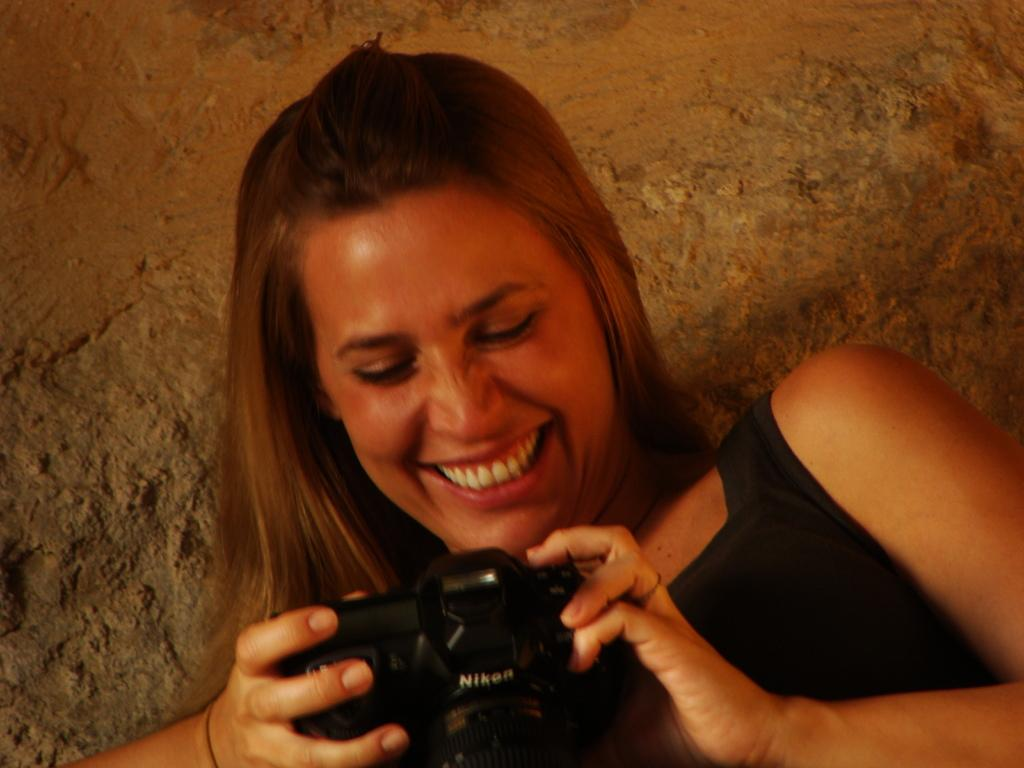Who is the main subject in the image? There is a woman in the image. What is the woman wearing? The woman is wearing a black dress. What is the woman holding in the image? The woman is holding a camera. What can be seen in the background of the image? There is a rock in the background of the image. How many chairs are visible in the image? There are no chairs present in the image. What type of books can be seen on the woman's lap? There are no books visible in the image; the woman is holding a camera. 